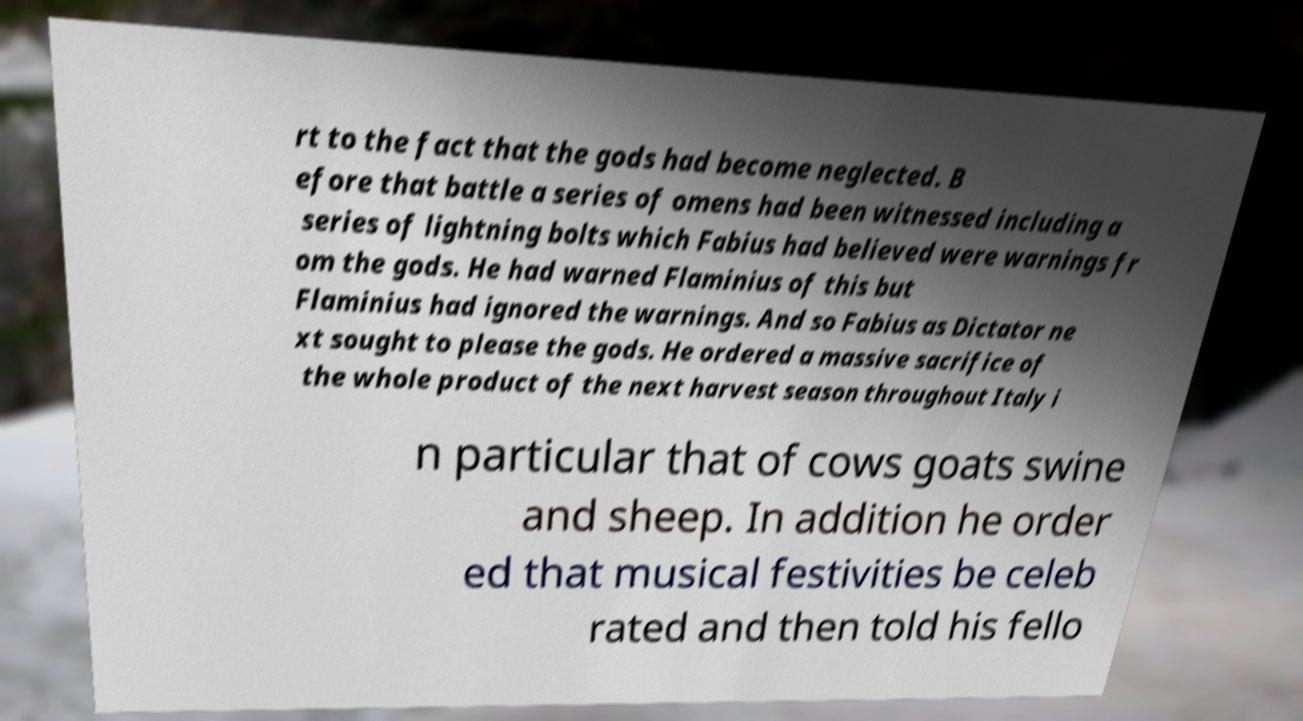Could you extract and type out the text from this image? rt to the fact that the gods had become neglected. B efore that battle a series of omens had been witnessed including a series of lightning bolts which Fabius had believed were warnings fr om the gods. He had warned Flaminius of this but Flaminius had ignored the warnings. And so Fabius as Dictator ne xt sought to please the gods. He ordered a massive sacrifice of the whole product of the next harvest season throughout Italy i n particular that of cows goats swine and sheep. In addition he order ed that musical festivities be celeb rated and then told his fello 